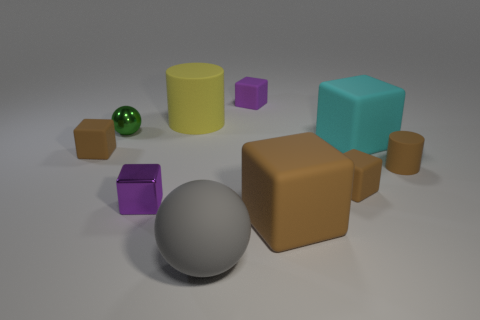What color is the small thing that is behind the big cyan object and to the right of the yellow rubber object?
Offer a very short reply. Purple. Is there another object of the same shape as the purple metallic object?
Provide a succinct answer. Yes. What is the big gray thing made of?
Your answer should be very brief. Rubber. Are there any cylinders in front of the tiny purple rubber object?
Ensure brevity in your answer.  Yes. Does the yellow rubber object have the same shape as the gray thing?
Your response must be concise. No. How many other objects are the same size as the green metal thing?
Give a very brief answer. 5. What number of things are either metal things in front of the cyan rubber thing or tiny green metal balls?
Provide a short and direct response. 2. The tiny metal sphere is what color?
Provide a succinct answer. Green. There is a tiny purple object in front of the cyan cube; what is it made of?
Make the answer very short. Metal. Does the cyan thing have the same shape as the small purple thing that is behind the big cyan matte object?
Give a very brief answer. Yes. 